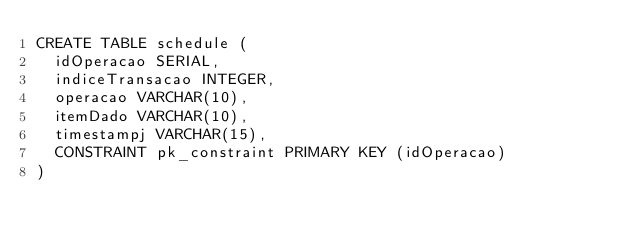<code> <loc_0><loc_0><loc_500><loc_500><_SQL_>CREATE TABLE schedule (
  idOperacao SERIAL,
  indiceTransacao INTEGER,
  operacao VARCHAR(10),
  itemDado VARCHAR(10),
  timestampj VARCHAR(15),
  CONSTRAINT pk_constraint PRIMARY KEY (idOperacao)
)</code> 